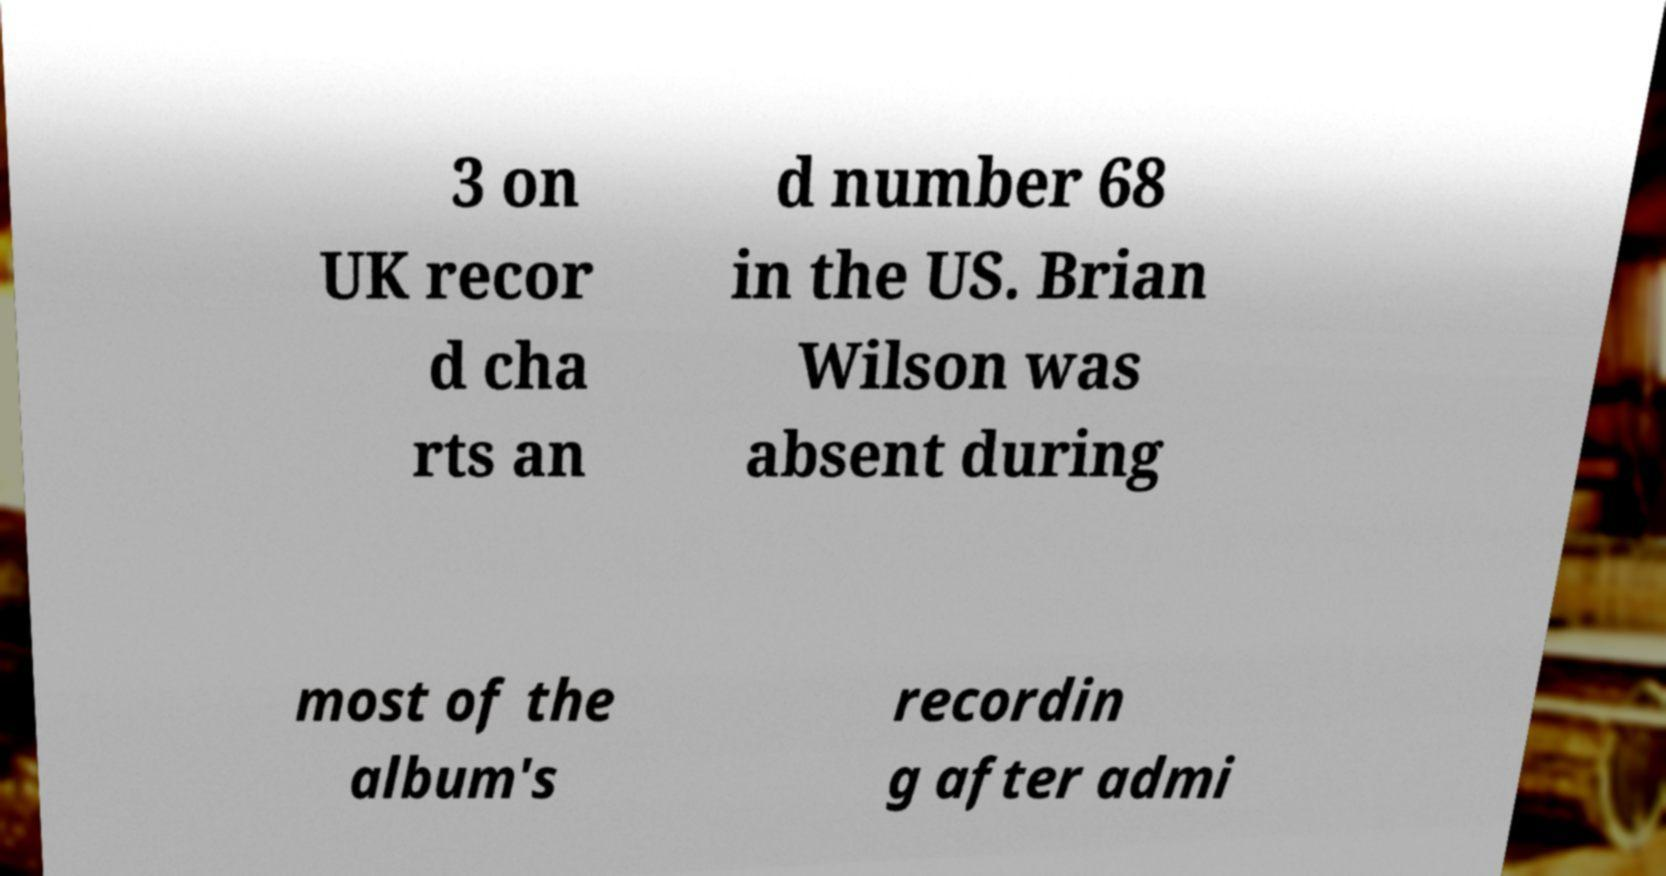Please identify and transcribe the text found in this image. 3 on UK recor d cha rts an d number 68 in the US. Brian Wilson was absent during most of the album's recordin g after admi 